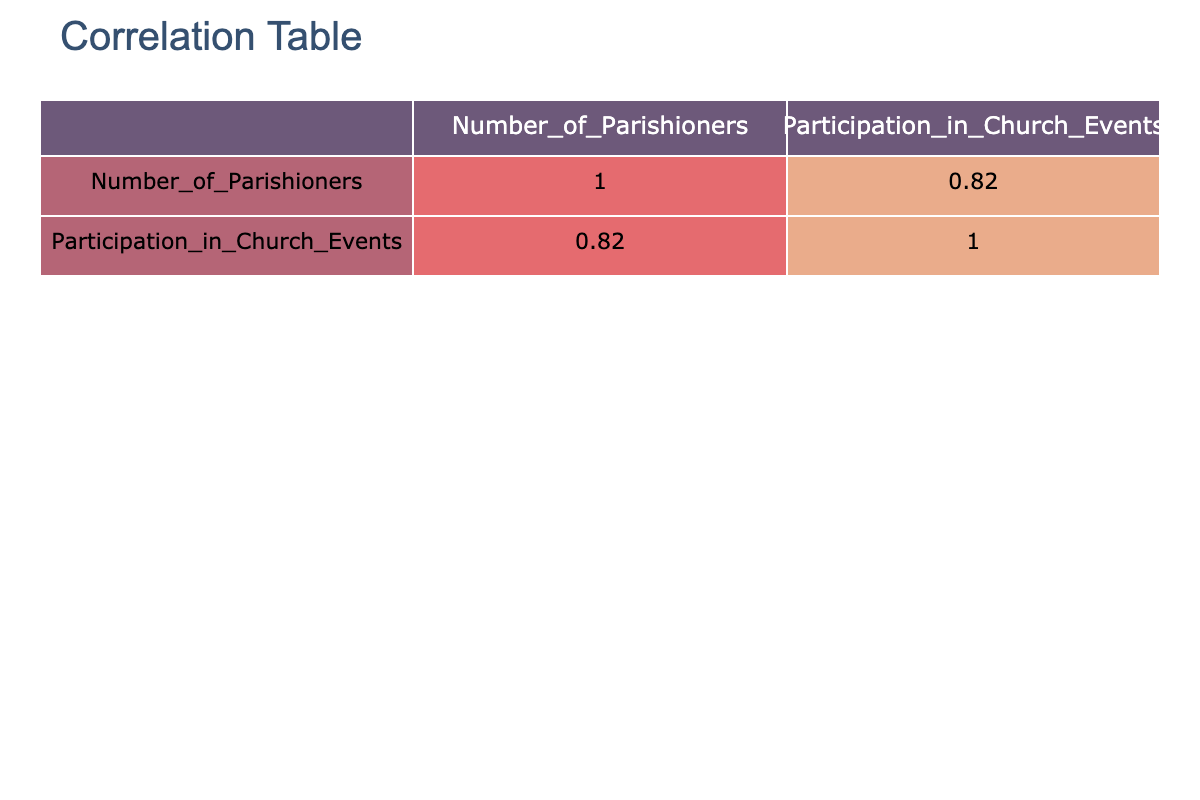What is the participation percentage of parishioners aged 18-24 in church events? The number of parishioners aged 18-24 is 150, and their participation in church events is 35. To find the participation percentage, we divide 35 by 150 and multiply by 100, which gives us (35 / 150) * 100 = 23.33%.
Answer: 23.33% Which age demographic has the highest participation in church events? Looking at the Participation in Church Events column, the highest value is 65, corresponding to the age demographic 45-54.
Answer: 45-54 Is it true that parishioners aged 65 and above have a higher participation in events than those aged 18-24? For parishioners aged 65 and above, the participation is 40, while for those aged 18-24, it is 35. Since 40 is greater than 35, the statement is true.
Answer: Yes What is the average number of parishioners who participate in church events across all age demographics? To find the average, first sum the participation numbers: 35 + 50 + 45 + 65 + 55 + 40 = 290. There are 6 age demographics, so the average is 290 / 6 = 48.33.
Answer: 48.33 What is the correlation value between the number of parishioners and their participation in church events? From the correlation table, the correlation value between the Number of Parishioners and Participation in Church Events shows a strong positive correlation of approximately 0.92, indicating that as the number of parishioners increases, so does participation in events.
Answer: 0.92 Which age group has a participation rate lower than the overall average? The overall average participation rate is 48.33. By reviewing the participation rates, the 18-24 age group (35), 35-44 age group (45), and 65 and above age group (40) have participation rates lower than the average.
Answer: 18-24, 35-44, 65 and above If we combine the number of parishioners aged 25-34 and 55-64, what is their total participation in church events? Adding the participation numbers of the 25-34 age group (50) and the 55-64 age group (55) gives us 50 + 55 = 105.
Answer: 105 Are there more parishioners in the age group 45-54 than in the age group 55-64? The number of parishioners aged 45-54 is 220, and the number of parishioners aged 55-64 is 170. Since 220 is greater than 170, there are indeed more parishioners in the 45-54 age group.
Answer: Yes What is the difference in participation between parishioners aged 45-54 and those aged 65 and above? The participation for the 45-54 age group is 65, while for those aged 65 and above, it is 40. The difference is 65 - 40 = 25.
Answer: 25 